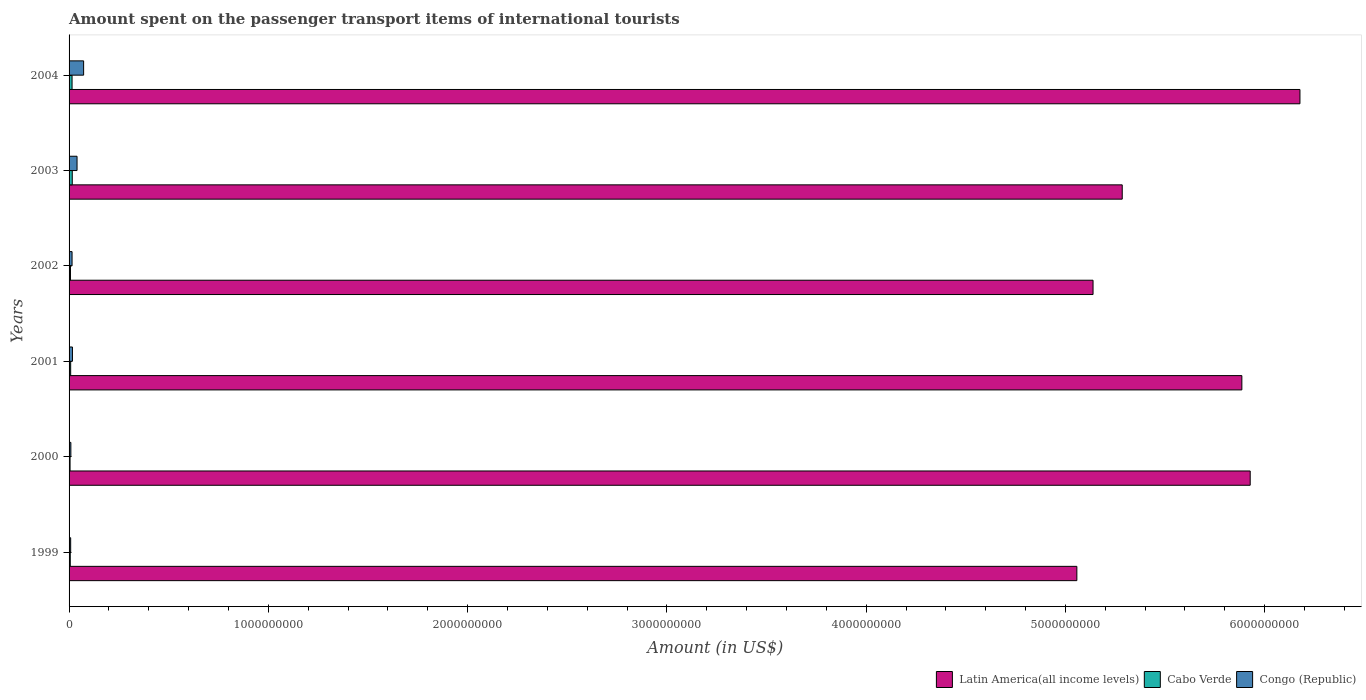How many bars are there on the 2nd tick from the top?
Make the answer very short. 3. What is the label of the 6th group of bars from the top?
Provide a succinct answer. 1999. In how many cases, is the number of bars for a given year not equal to the number of legend labels?
Offer a very short reply. 0. What is the amount spent on the passenger transport items of international tourists in Congo (Republic) in 2003?
Provide a short and direct response. 4.00e+07. Across all years, what is the maximum amount spent on the passenger transport items of international tourists in Latin America(all income levels)?
Provide a short and direct response. 6.18e+09. Across all years, what is the minimum amount spent on the passenger transport items of international tourists in Cabo Verde?
Provide a succinct answer. 5.00e+06. In which year was the amount spent on the passenger transport items of international tourists in Cabo Verde minimum?
Make the answer very short. 2000. What is the total amount spent on the passenger transport items of international tourists in Latin America(all income levels) in the graph?
Provide a succinct answer. 3.35e+1. What is the difference between the amount spent on the passenger transport items of international tourists in Latin America(all income levels) in 2002 and that in 2003?
Provide a succinct answer. -1.46e+08. What is the difference between the amount spent on the passenger transport items of international tourists in Congo (Republic) in 1999 and the amount spent on the passenger transport items of international tourists in Latin America(all income levels) in 2002?
Make the answer very short. -5.13e+09. What is the average amount spent on the passenger transport items of international tourists in Congo (Republic) per year?
Provide a succinct answer. 2.70e+07. In the year 2001, what is the difference between the amount spent on the passenger transport items of international tourists in Congo (Republic) and amount spent on the passenger transport items of international tourists in Latin America(all income levels)?
Provide a short and direct response. -5.87e+09. In how many years, is the amount spent on the passenger transport items of international tourists in Cabo Verde greater than 4000000000 US$?
Your response must be concise. 0. What is the ratio of the amount spent on the passenger transport items of international tourists in Congo (Republic) in 2000 to that in 2003?
Provide a succinct answer. 0.23. Is the difference between the amount spent on the passenger transport items of international tourists in Congo (Republic) in 2002 and 2004 greater than the difference between the amount spent on the passenger transport items of international tourists in Latin America(all income levels) in 2002 and 2004?
Offer a very short reply. Yes. What is the difference between the highest and the second highest amount spent on the passenger transport items of international tourists in Latin America(all income levels)?
Provide a succinct answer. 2.50e+08. What is the difference between the highest and the lowest amount spent on the passenger transport items of international tourists in Latin America(all income levels)?
Offer a terse response. 1.12e+09. In how many years, is the amount spent on the passenger transport items of international tourists in Cabo Verde greater than the average amount spent on the passenger transport items of international tourists in Cabo Verde taken over all years?
Keep it short and to the point. 2. What does the 3rd bar from the top in 2003 represents?
Your answer should be very brief. Latin America(all income levels). What does the 3rd bar from the bottom in 2002 represents?
Provide a short and direct response. Congo (Republic). Is it the case that in every year, the sum of the amount spent on the passenger transport items of international tourists in Cabo Verde and amount spent on the passenger transport items of international tourists in Congo (Republic) is greater than the amount spent on the passenger transport items of international tourists in Latin America(all income levels)?
Your answer should be very brief. No. Are all the bars in the graph horizontal?
Offer a very short reply. Yes. How many years are there in the graph?
Give a very brief answer. 6. Are the values on the major ticks of X-axis written in scientific E-notation?
Give a very brief answer. No. Does the graph contain grids?
Your answer should be compact. No. How are the legend labels stacked?
Provide a short and direct response. Horizontal. What is the title of the graph?
Give a very brief answer. Amount spent on the passenger transport items of international tourists. What is the label or title of the X-axis?
Provide a short and direct response. Amount (in US$). What is the label or title of the Y-axis?
Offer a terse response. Years. What is the Amount (in US$) in Latin America(all income levels) in 1999?
Your answer should be compact. 5.06e+09. What is the Amount (in US$) in Congo (Republic) in 1999?
Offer a terse response. 8.00e+06. What is the Amount (in US$) in Latin America(all income levels) in 2000?
Your answer should be compact. 5.93e+09. What is the Amount (in US$) in Cabo Verde in 2000?
Offer a very short reply. 5.00e+06. What is the Amount (in US$) in Congo (Republic) in 2000?
Provide a short and direct response. 9.00e+06. What is the Amount (in US$) in Latin America(all income levels) in 2001?
Make the answer very short. 5.89e+09. What is the Amount (in US$) in Congo (Republic) in 2001?
Ensure brevity in your answer.  1.70e+07. What is the Amount (in US$) in Latin America(all income levels) in 2002?
Ensure brevity in your answer.  5.14e+09. What is the Amount (in US$) in Cabo Verde in 2002?
Your answer should be very brief. 7.00e+06. What is the Amount (in US$) of Congo (Republic) in 2002?
Provide a succinct answer. 1.50e+07. What is the Amount (in US$) in Latin America(all income levels) in 2003?
Ensure brevity in your answer.  5.29e+09. What is the Amount (in US$) in Cabo Verde in 2003?
Keep it short and to the point. 1.60e+07. What is the Amount (in US$) of Congo (Republic) in 2003?
Give a very brief answer. 4.00e+07. What is the Amount (in US$) in Latin America(all income levels) in 2004?
Keep it short and to the point. 6.18e+09. What is the Amount (in US$) in Cabo Verde in 2004?
Make the answer very short. 1.50e+07. What is the Amount (in US$) in Congo (Republic) in 2004?
Provide a short and direct response. 7.30e+07. Across all years, what is the maximum Amount (in US$) of Latin America(all income levels)?
Give a very brief answer. 6.18e+09. Across all years, what is the maximum Amount (in US$) of Cabo Verde?
Offer a terse response. 1.60e+07. Across all years, what is the maximum Amount (in US$) of Congo (Republic)?
Make the answer very short. 7.30e+07. Across all years, what is the minimum Amount (in US$) in Latin America(all income levels)?
Provide a succinct answer. 5.06e+09. What is the total Amount (in US$) of Latin America(all income levels) in the graph?
Offer a terse response. 3.35e+1. What is the total Amount (in US$) in Cabo Verde in the graph?
Make the answer very short. 5.70e+07. What is the total Amount (in US$) in Congo (Republic) in the graph?
Make the answer very short. 1.62e+08. What is the difference between the Amount (in US$) in Latin America(all income levels) in 1999 and that in 2000?
Make the answer very short. -8.70e+08. What is the difference between the Amount (in US$) of Cabo Verde in 1999 and that in 2000?
Give a very brief answer. 1.00e+06. What is the difference between the Amount (in US$) in Latin America(all income levels) in 1999 and that in 2001?
Provide a short and direct response. -8.28e+08. What is the difference between the Amount (in US$) in Cabo Verde in 1999 and that in 2001?
Offer a very short reply. -2.00e+06. What is the difference between the Amount (in US$) of Congo (Republic) in 1999 and that in 2001?
Provide a short and direct response. -9.00e+06. What is the difference between the Amount (in US$) in Latin America(all income levels) in 1999 and that in 2002?
Give a very brief answer. -8.12e+07. What is the difference between the Amount (in US$) in Cabo Verde in 1999 and that in 2002?
Provide a succinct answer. -1.00e+06. What is the difference between the Amount (in US$) of Congo (Republic) in 1999 and that in 2002?
Provide a short and direct response. -7.00e+06. What is the difference between the Amount (in US$) in Latin America(all income levels) in 1999 and that in 2003?
Offer a very short reply. -2.28e+08. What is the difference between the Amount (in US$) of Cabo Verde in 1999 and that in 2003?
Your response must be concise. -1.00e+07. What is the difference between the Amount (in US$) of Congo (Republic) in 1999 and that in 2003?
Offer a very short reply. -3.20e+07. What is the difference between the Amount (in US$) of Latin America(all income levels) in 1999 and that in 2004?
Provide a short and direct response. -1.12e+09. What is the difference between the Amount (in US$) in Cabo Verde in 1999 and that in 2004?
Your answer should be compact. -9.00e+06. What is the difference between the Amount (in US$) in Congo (Republic) in 1999 and that in 2004?
Give a very brief answer. -6.50e+07. What is the difference between the Amount (in US$) in Latin America(all income levels) in 2000 and that in 2001?
Give a very brief answer. 4.18e+07. What is the difference between the Amount (in US$) in Congo (Republic) in 2000 and that in 2001?
Keep it short and to the point. -8.00e+06. What is the difference between the Amount (in US$) in Latin America(all income levels) in 2000 and that in 2002?
Make the answer very short. 7.89e+08. What is the difference between the Amount (in US$) of Cabo Verde in 2000 and that in 2002?
Your response must be concise. -2.00e+06. What is the difference between the Amount (in US$) in Congo (Republic) in 2000 and that in 2002?
Offer a very short reply. -6.00e+06. What is the difference between the Amount (in US$) in Latin America(all income levels) in 2000 and that in 2003?
Make the answer very short. 6.42e+08. What is the difference between the Amount (in US$) in Cabo Verde in 2000 and that in 2003?
Your answer should be very brief. -1.10e+07. What is the difference between the Amount (in US$) in Congo (Republic) in 2000 and that in 2003?
Ensure brevity in your answer.  -3.10e+07. What is the difference between the Amount (in US$) in Latin America(all income levels) in 2000 and that in 2004?
Ensure brevity in your answer.  -2.50e+08. What is the difference between the Amount (in US$) in Cabo Verde in 2000 and that in 2004?
Offer a very short reply. -1.00e+07. What is the difference between the Amount (in US$) in Congo (Republic) in 2000 and that in 2004?
Provide a succinct answer. -6.40e+07. What is the difference between the Amount (in US$) of Latin America(all income levels) in 2001 and that in 2002?
Provide a succinct answer. 7.47e+08. What is the difference between the Amount (in US$) of Cabo Verde in 2001 and that in 2002?
Your answer should be very brief. 1.00e+06. What is the difference between the Amount (in US$) in Congo (Republic) in 2001 and that in 2002?
Your answer should be very brief. 2.00e+06. What is the difference between the Amount (in US$) of Latin America(all income levels) in 2001 and that in 2003?
Your response must be concise. 6.00e+08. What is the difference between the Amount (in US$) of Cabo Verde in 2001 and that in 2003?
Keep it short and to the point. -8.00e+06. What is the difference between the Amount (in US$) in Congo (Republic) in 2001 and that in 2003?
Give a very brief answer. -2.30e+07. What is the difference between the Amount (in US$) of Latin America(all income levels) in 2001 and that in 2004?
Provide a short and direct response. -2.91e+08. What is the difference between the Amount (in US$) of Cabo Verde in 2001 and that in 2004?
Give a very brief answer. -7.00e+06. What is the difference between the Amount (in US$) in Congo (Republic) in 2001 and that in 2004?
Offer a terse response. -5.60e+07. What is the difference between the Amount (in US$) in Latin America(all income levels) in 2002 and that in 2003?
Your response must be concise. -1.46e+08. What is the difference between the Amount (in US$) in Cabo Verde in 2002 and that in 2003?
Your answer should be very brief. -9.00e+06. What is the difference between the Amount (in US$) in Congo (Republic) in 2002 and that in 2003?
Offer a very short reply. -2.50e+07. What is the difference between the Amount (in US$) of Latin America(all income levels) in 2002 and that in 2004?
Give a very brief answer. -1.04e+09. What is the difference between the Amount (in US$) in Cabo Verde in 2002 and that in 2004?
Offer a terse response. -8.00e+06. What is the difference between the Amount (in US$) in Congo (Republic) in 2002 and that in 2004?
Your answer should be very brief. -5.80e+07. What is the difference between the Amount (in US$) in Latin America(all income levels) in 2003 and that in 2004?
Provide a succinct answer. -8.92e+08. What is the difference between the Amount (in US$) of Congo (Republic) in 2003 and that in 2004?
Keep it short and to the point. -3.30e+07. What is the difference between the Amount (in US$) of Latin America(all income levels) in 1999 and the Amount (in US$) of Cabo Verde in 2000?
Provide a short and direct response. 5.05e+09. What is the difference between the Amount (in US$) of Latin America(all income levels) in 1999 and the Amount (in US$) of Congo (Republic) in 2000?
Your answer should be compact. 5.05e+09. What is the difference between the Amount (in US$) in Cabo Verde in 1999 and the Amount (in US$) in Congo (Republic) in 2000?
Your answer should be very brief. -3.00e+06. What is the difference between the Amount (in US$) in Latin America(all income levels) in 1999 and the Amount (in US$) in Cabo Verde in 2001?
Provide a succinct answer. 5.05e+09. What is the difference between the Amount (in US$) of Latin America(all income levels) in 1999 and the Amount (in US$) of Congo (Republic) in 2001?
Offer a very short reply. 5.04e+09. What is the difference between the Amount (in US$) in Cabo Verde in 1999 and the Amount (in US$) in Congo (Republic) in 2001?
Give a very brief answer. -1.10e+07. What is the difference between the Amount (in US$) in Latin America(all income levels) in 1999 and the Amount (in US$) in Cabo Verde in 2002?
Provide a short and direct response. 5.05e+09. What is the difference between the Amount (in US$) in Latin America(all income levels) in 1999 and the Amount (in US$) in Congo (Republic) in 2002?
Give a very brief answer. 5.04e+09. What is the difference between the Amount (in US$) in Cabo Verde in 1999 and the Amount (in US$) in Congo (Republic) in 2002?
Give a very brief answer. -9.00e+06. What is the difference between the Amount (in US$) of Latin America(all income levels) in 1999 and the Amount (in US$) of Cabo Verde in 2003?
Make the answer very short. 5.04e+09. What is the difference between the Amount (in US$) in Latin America(all income levels) in 1999 and the Amount (in US$) in Congo (Republic) in 2003?
Make the answer very short. 5.02e+09. What is the difference between the Amount (in US$) in Cabo Verde in 1999 and the Amount (in US$) in Congo (Republic) in 2003?
Your answer should be very brief. -3.40e+07. What is the difference between the Amount (in US$) in Latin America(all income levels) in 1999 and the Amount (in US$) in Cabo Verde in 2004?
Ensure brevity in your answer.  5.04e+09. What is the difference between the Amount (in US$) of Latin America(all income levels) in 1999 and the Amount (in US$) of Congo (Republic) in 2004?
Keep it short and to the point. 4.98e+09. What is the difference between the Amount (in US$) of Cabo Verde in 1999 and the Amount (in US$) of Congo (Republic) in 2004?
Make the answer very short. -6.70e+07. What is the difference between the Amount (in US$) of Latin America(all income levels) in 2000 and the Amount (in US$) of Cabo Verde in 2001?
Your answer should be very brief. 5.92e+09. What is the difference between the Amount (in US$) in Latin America(all income levels) in 2000 and the Amount (in US$) in Congo (Republic) in 2001?
Make the answer very short. 5.91e+09. What is the difference between the Amount (in US$) of Cabo Verde in 2000 and the Amount (in US$) of Congo (Republic) in 2001?
Your answer should be very brief. -1.20e+07. What is the difference between the Amount (in US$) of Latin America(all income levels) in 2000 and the Amount (in US$) of Cabo Verde in 2002?
Ensure brevity in your answer.  5.92e+09. What is the difference between the Amount (in US$) of Latin America(all income levels) in 2000 and the Amount (in US$) of Congo (Republic) in 2002?
Offer a terse response. 5.91e+09. What is the difference between the Amount (in US$) in Cabo Verde in 2000 and the Amount (in US$) in Congo (Republic) in 2002?
Your response must be concise. -1.00e+07. What is the difference between the Amount (in US$) of Latin America(all income levels) in 2000 and the Amount (in US$) of Cabo Verde in 2003?
Make the answer very short. 5.91e+09. What is the difference between the Amount (in US$) in Latin America(all income levels) in 2000 and the Amount (in US$) in Congo (Republic) in 2003?
Keep it short and to the point. 5.89e+09. What is the difference between the Amount (in US$) in Cabo Verde in 2000 and the Amount (in US$) in Congo (Republic) in 2003?
Offer a very short reply. -3.50e+07. What is the difference between the Amount (in US$) of Latin America(all income levels) in 2000 and the Amount (in US$) of Cabo Verde in 2004?
Your answer should be very brief. 5.91e+09. What is the difference between the Amount (in US$) of Latin America(all income levels) in 2000 and the Amount (in US$) of Congo (Republic) in 2004?
Keep it short and to the point. 5.85e+09. What is the difference between the Amount (in US$) in Cabo Verde in 2000 and the Amount (in US$) in Congo (Republic) in 2004?
Keep it short and to the point. -6.80e+07. What is the difference between the Amount (in US$) in Latin America(all income levels) in 2001 and the Amount (in US$) in Cabo Verde in 2002?
Give a very brief answer. 5.88e+09. What is the difference between the Amount (in US$) in Latin America(all income levels) in 2001 and the Amount (in US$) in Congo (Republic) in 2002?
Make the answer very short. 5.87e+09. What is the difference between the Amount (in US$) of Cabo Verde in 2001 and the Amount (in US$) of Congo (Republic) in 2002?
Provide a succinct answer. -7.00e+06. What is the difference between the Amount (in US$) of Latin America(all income levels) in 2001 and the Amount (in US$) of Cabo Verde in 2003?
Keep it short and to the point. 5.87e+09. What is the difference between the Amount (in US$) of Latin America(all income levels) in 2001 and the Amount (in US$) of Congo (Republic) in 2003?
Ensure brevity in your answer.  5.85e+09. What is the difference between the Amount (in US$) in Cabo Verde in 2001 and the Amount (in US$) in Congo (Republic) in 2003?
Give a very brief answer. -3.20e+07. What is the difference between the Amount (in US$) in Latin America(all income levels) in 2001 and the Amount (in US$) in Cabo Verde in 2004?
Make the answer very short. 5.87e+09. What is the difference between the Amount (in US$) in Latin America(all income levels) in 2001 and the Amount (in US$) in Congo (Republic) in 2004?
Your answer should be compact. 5.81e+09. What is the difference between the Amount (in US$) of Cabo Verde in 2001 and the Amount (in US$) of Congo (Republic) in 2004?
Offer a very short reply. -6.50e+07. What is the difference between the Amount (in US$) in Latin America(all income levels) in 2002 and the Amount (in US$) in Cabo Verde in 2003?
Give a very brief answer. 5.12e+09. What is the difference between the Amount (in US$) of Latin America(all income levels) in 2002 and the Amount (in US$) of Congo (Republic) in 2003?
Give a very brief answer. 5.10e+09. What is the difference between the Amount (in US$) in Cabo Verde in 2002 and the Amount (in US$) in Congo (Republic) in 2003?
Keep it short and to the point. -3.30e+07. What is the difference between the Amount (in US$) of Latin America(all income levels) in 2002 and the Amount (in US$) of Cabo Verde in 2004?
Ensure brevity in your answer.  5.12e+09. What is the difference between the Amount (in US$) in Latin America(all income levels) in 2002 and the Amount (in US$) in Congo (Republic) in 2004?
Provide a short and direct response. 5.07e+09. What is the difference between the Amount (in US$) of Cabo Verde in 2002 and the Amount (in US$) of Congo (Republic) in 2004?
Ensure brevity in your answer.  -6.60e+07. What is the difference between the Amount (in US$) of Latin America(all income levels) in 2003 and the Amount (in US$) of Cabo Verde in 2004?
Make the answer very short. 5.27e+09. What is the difference between the Amount (in US$) in Latin America(all income levels) in 2003 and the Amount (in US$) in Congo (Republic) in 2004?
Offer a terse response. 5.21e+09. What is the difference between the Amount (in US$) of Cabo Verde in 2003 and the Amount (in US$) of Congo (Republic) in 2004?
Offer a terse response. -5.70e+07. What is the average Amount (in US$) in Latin America(all income levels) per year?
Make the answer very short. 5.58e+09. What is the average Amount (in US$) of Cabo Verde per year?
Provide a succinct answer. 9.50e+06. What is the average Amount (in US$) in Congo (Republic) per year?
Your answer should be very brief. 2.70e+07. In the year 1999, what is the difference between the Amount (in US$) in Latin America(all income levels) and Amount (in US$) in Cabo Verde?
Offer a very short reply. 5.05e+09. In the year 1999, what is the difference between the Amount (in US$) of Latin America(all income levels) and Amount (in US$) of Congo (Republic)?
Provide a succinct answer. 5.05e+09. In the year 2000, what is the difference between the Amount (in US$) in Latin America(all income levels) and Amount (in US$) in Cabo Verde?
Provide a short and direct response. 5.92e+09. In the year 2000, what is the difference between the Amount (in US$) of Latin America(all income levels) and Amount (in US$) of Congo (Republic)?
Make the answer very short. 5.92e+09. In the year 2001, what is the difference between the Amount (in US$) of Latin America(all income levels) and Amount (in US$) of Cabo Verde?
Offer a very short reply. 5.88e+09. In the year 2001, what is the difference between the Amount (in US$) of Latin America(all income levels) and Amount (in US$) of Congo (Republic)?
Offer a very short reply. 5.87e+09. In the year 2001, what is the difference between the Amount (in US$) of Cabo Verde and Amount (in US$) of Congo (Republic)?
Offer a very short reply. -9.00e+06. In the year 2002, what is the difference between the Amount (in US$) of Latin America(all income levels) and Amount (in US$) of Cabo Verde?
Offer a terse response. 5.13e+09. In the year 2002, what is the difference between the Amount (in US$) in Latin America(all income levels) and Amount (in US$) in Congo (Republic)?
Offer a very short reply. 5.12e+09. In the year 2002, what is the difference between the Amount (in US$) in Cabo Verde and Amount (in US$) in Congo (Republic)?
Your answer should be very brief. -8.00e+06. In the year 2003, what is the difference between the Amount (in US$) of Latin America(all income levels) and Amount (in US$) of Cabo Verde?
Your answer should be compact. 5.27e+09. In the year 2003, what is the difference between the Amount (in US$) in Latin America(all income levels) and Amount (in US$) in Congo (Republic)?
Provide a short and direct response. 5.25e+09. In the year 2003, what is the difference between the Amount (in US$) of Cabo Verde and Amount (in US$) of Congo (Republic)?
Ensure brevity in your answer.  -2.40e+07. In the year 2004, what is the difference between the Amount (in US$) in Latin America(all income levels) and Amount (in US$) in Cabo Verde?
Offer a terse response. 6.16e+09. In the year 2004, what is the difference between the Amount (in US$) of Latin America(all income levels) and Amount (in US$) of Congo (Republic)?
Ensure brevity in your answer.  6.10e+09. In the year 2004, what is the difference between the Amount (in US$) in Cabo Verde and Amount (in US$) in Congo (Republic)?
Give a very brief answer. -5.80e+07. What is the ratio of the Amount (in US$) of Latin America(all income levels) in 1999 to that in 2000?
Ensure brevity in your answer.  0.85. What is the ratio of the Amount (in US$) in Cabo Verde in 1999 to that in 2000?
Offer a very short reply. 1.2. What is the ratio of the Amount (in US$) in Congo (Republic) in 1999 to that in 2000?
Give a very brief answer. 0.89. What is the ratio of the Amount (in US$) in Latin America(all income levels) in 1999 to that in 2001?
Offer a very short reply. 0.86. What is the ratio of the Amount (in US$) of Congo (Republic) in 1999 to that in 2001?
Provide a succinct answer. 0.47. What is the ratio of the Amount (in US$) of Latin America(all income levels) in 1999 to that in 2002?
Your answer should be very brief. 0.98. What is the ratio of the Amount (in US$) of Cabo Verde in 1999 to that in 2002?
Offer a very short reply. 0.86. What is the ratio of the Amount (in US$) of Congo (Republic) in 1999 to that in 2002?
Your answer should be compact. 0.53. What is the ratio of the Amount (in US$) in Latin America(all income levels) in 1999 to that in 2003?
Provide a succinct answer. 0.96. What is the ratio of the Amount (in US$) in Congo (Republic) in 1999 to that in 2003?
Offer a terse response. 0.2. What is the ratio of the Amount (in US$) of Latin America(all income levels) in 1999 to that in 2004?
Provide a succinct answer. 0.82. What is the ratio of the Amount (in US$) of Congo (Republic) in 1999 to that in 2004?
Make the answer very short. 0.11. What is the ratio of the Amount (in US$) in Latin America(all income levels) in 2000 to that in 2001?
Your answer should be compact. 1.01. What is the ratio of the Amount (in US$) of Congo (Republic) in 2000 to that in 2001?
Your response must be concise. 0.53. What is the ratio of the Amount (in US$) in Latin America(all income levels) in 2000 to that in 2002?
Your response must be concise. 1.15. What is the ratio of the Amount (in US$) in Cabo Verde in 2000 to that in 2002?
Give a very brief answer. 0.71. What is the ratio of the Amount (in US$) in Latin America(all income levels) in 2000 to that in 2003?
Provide a succinct answer. 1.12. What is the ratio of the Amount (in US$) of Cabo Verde in 2000 to that in 2003?
Your answer should be compact. 0.31. What is the ratio of the Amount (in US$) in Congo (Republic) in 2000 to that in 2003?
Offer a terse response. 0.23. What is the ratio of the Amount (in US$) of Latin America(all income levels) in 2000 to that in 2004?
Your answer should be compact. 0.96. What is the ratio of the Amount (in US$) of Cabo Verde in 2000 to that in 2004?
Your response must be concise. 0.33. What is the ratio of the Amount (in US$) of Congo (Republic) in 2000 to that in 2004?
Provide a short and direct response. 0.12. What is the ratio of the Amount (in US$) of Latin America(all income levels) in 2001 to that in 2002?
Make the answer very short. 1.15. What is the ratio of the Amount (in US$) of Cabo Verde in 2001 to that in 2002?
Make the answer very short. 1.14. What is the ratio of the Amount (in US$) in Congo (Republic) in 2001 to that in 2002?
Your answer should be very brief. 1.13. What is the ratio of the Amount (in US$) in Latin America(all income levels) in 2001 to that in 2003?
Provide a short and direct response. 1.11. What is the ratio of the Amount (in US$) of Congo (Republic) in 2001 to that in 2003?
Your answer should be very brief. 0.42. What is the ratio of the Amount (in US$) of Latin America(all income levels) in 2001 to that in 2004?
Offer a very short reply. 0.95. What is the ratio of the Amount (in US$) of Cabo Verde in 2001 to that in 2004?
Ensure brevity in your answer.  0.53. What is the ratio of the Amount (in US$) of Congo (Republic) in 2001 to that in 2004?
Your answer should be compact. 0.23. What is the ratio of the Amount (in US$) in Latin America(all income levels) in 2002 to that in 2003?
Ensure brevity in your answer.  0.97. What is the ratio of the Amount (in US$) in Cabo Verde in 2002 to that in 2003?
Give a very brief answer. 0.44. What is the ratio of the Amount (in US$) of Latin America(all income levels) in 2002 to that in 2004?
Provide a succinct answer. 0.83. What is the ratio of the Amount (in US$) in Cabo Verde in 2002 to that in 2004?
Keep it short and to the point. 0.47. What is the ratio of the Amount (in US$) of Congo (Republic) in 2002 to that in 2004?
Offer a terse response. 0.21. What is the ratio of the Amount (in US$) of Latin America(all income levels) in 2003 to that in 2004?
Keep it short and to the point. 0.86. What is the ratio of the Amount (in US$) of Cabo Verde in 2003 to that in 2004?
Offer a terse response. 1.07. What is the ratio of the Amount (in US$) in Congo (Republic) in 2003 to that in 2004?
Your answer should be very brief. 0.55. What is the difference between the highest and the second highest Amount (in US$) of Latin America(all income levels)?
Your answer should be very brief. 2.50e+08. What is the difference between the highest and the second highest Amount (in US$) of Congo (Republic)?
Keep it short and to the point. 3.30e+07. What is the difference between the highest and the lowest Amount (in US$) of Latin America(all income levels)?
Give a very brief answer. 1.12e+09. What is the difference between the highest and the lowest Amount (in US$) of Cabo Verde?
Ensure brevity in your answer.  1.10e+07. What is the difference between the highest and the lowest Amount (in US$) in Congo (Republic)?
Give a very brief answer. 6.50e+07. 